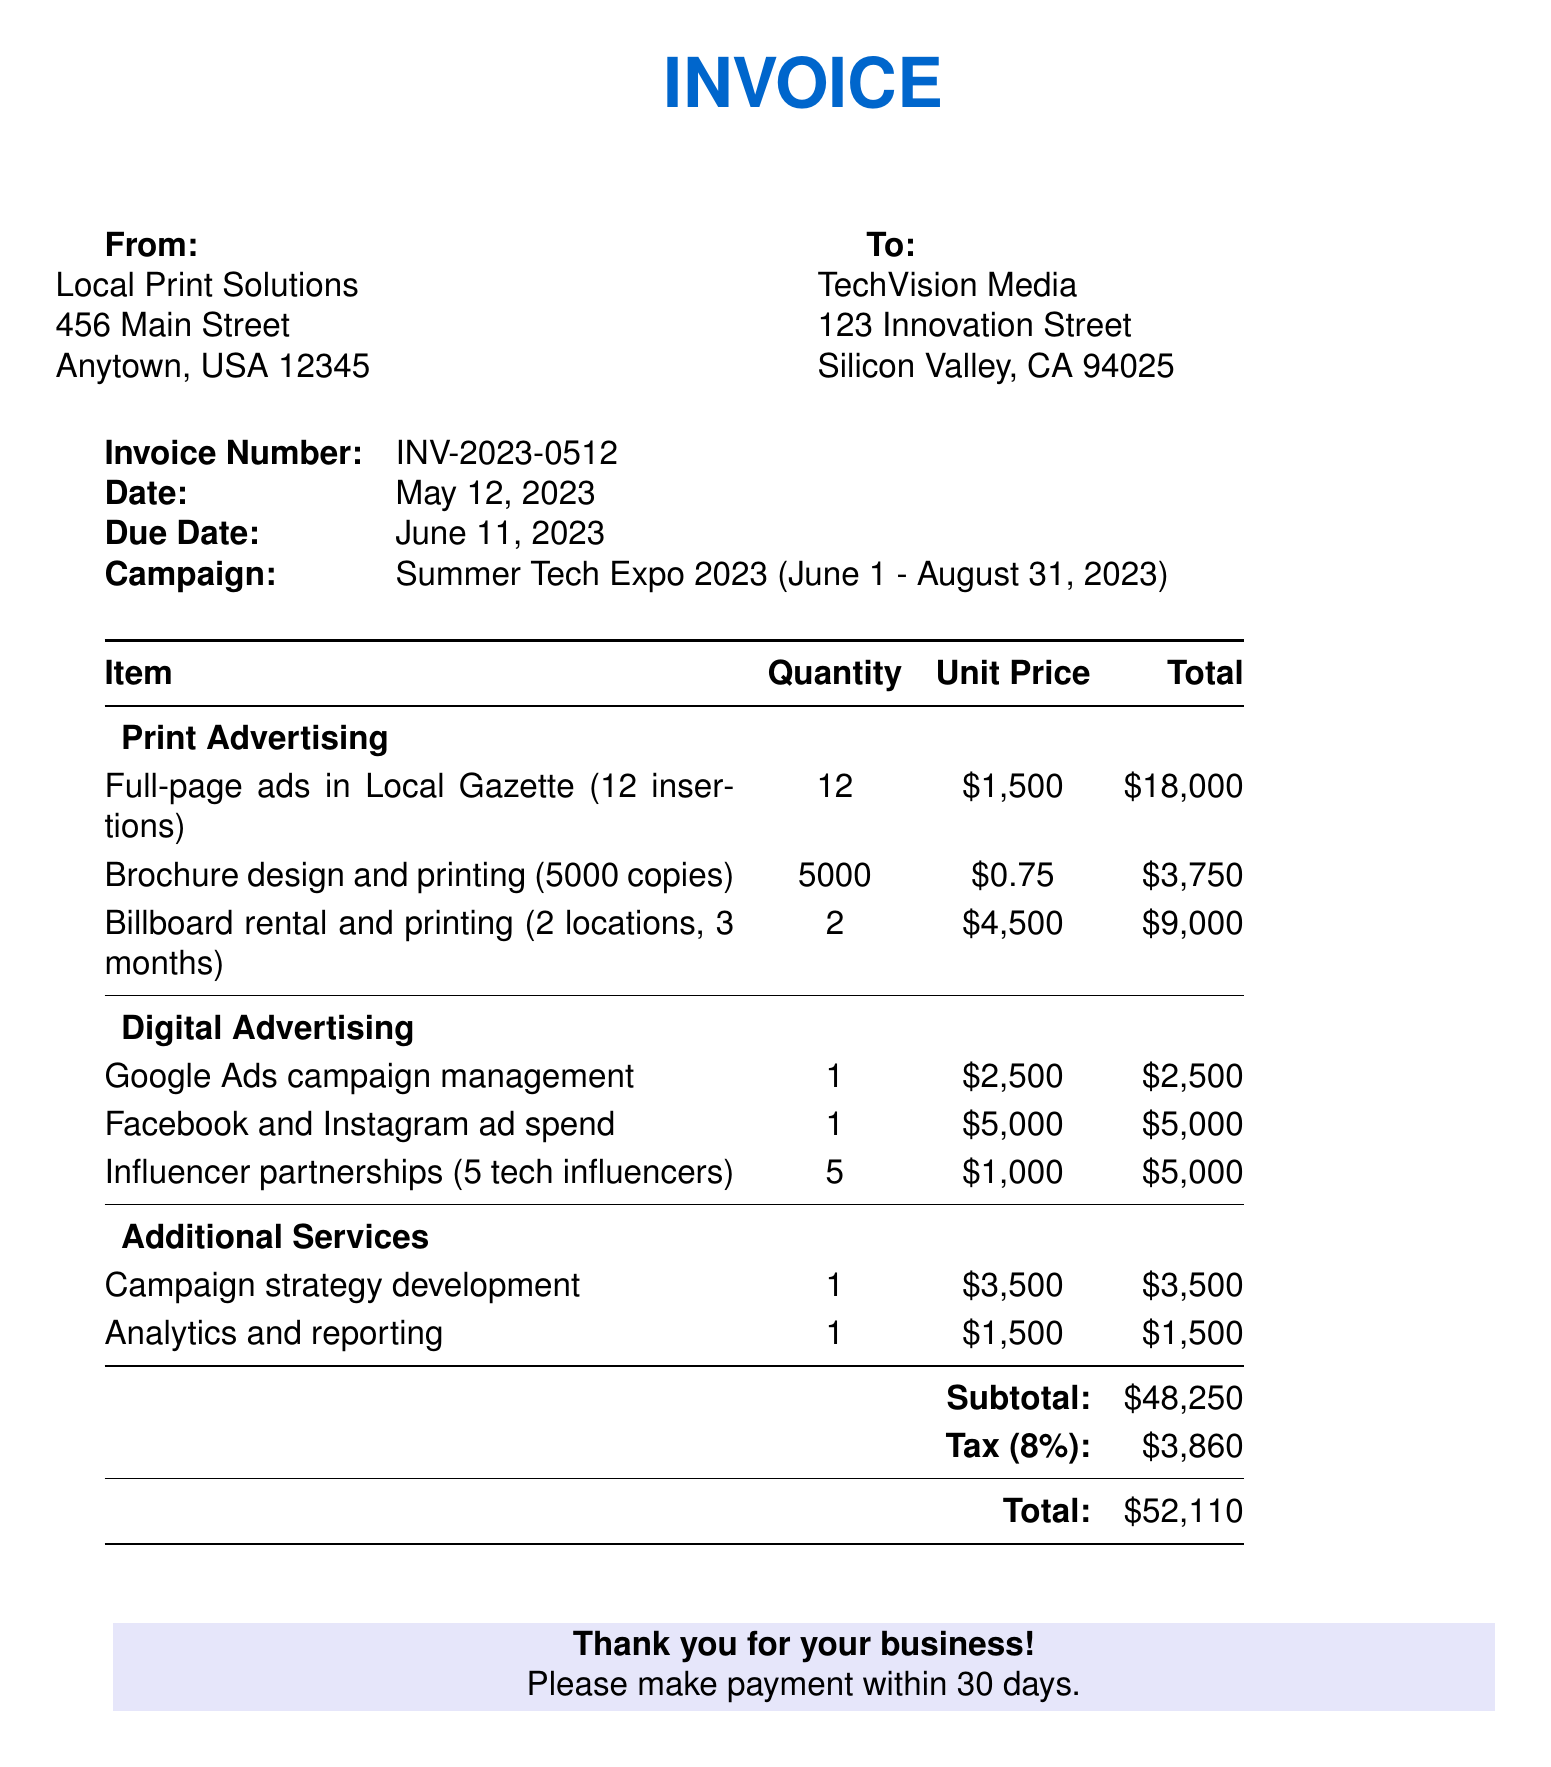What is the invoice number? The invoice number is specified in the top section of the document for reference, which is INV-2023-0512.
Answer: INV-2023-0512 What is the subtotal amount? The subtotal amount is the total of all expenses listed before tax in the invoice, which is $48,250.
Answer: $48,250 How many full-page ads are included? The quantity of full-page ads can be found under the print advertising section, which lists 12 insertions.
Answer: 12 What is the due date of the invoice? The due date is listed in the invoice details, which is June 11, 2023.
Answer: June 11, 2023 What is the total amount after tax? The total amount is calculated by adding the tax to the subtotal, which totals $52,110 in the invoice.
Answer: $52,110 What is the tax rate applied? The tax rate is mentioned as a percentage in the invoice, which is 8%.
Answer: 8% What is the total cost for influencer partnerships? The total cost for influencer partnerships is detailed in the digital advertising section, which is $5,000.
Answer: $5,000 How many locations are listed for billboard rental? The number of locations for billboard rental is specified in the print advertising section, which is 2 locations.
Answer: 2 What is the quantity of brochures printed? The quantity of brochures printed is specified in the print advertising section, which indicates 5000 copies.
Answer: 5000 